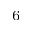<formula> <loc_0><loc_0><loc_500><loc_500>_ { 6 }</formula> 